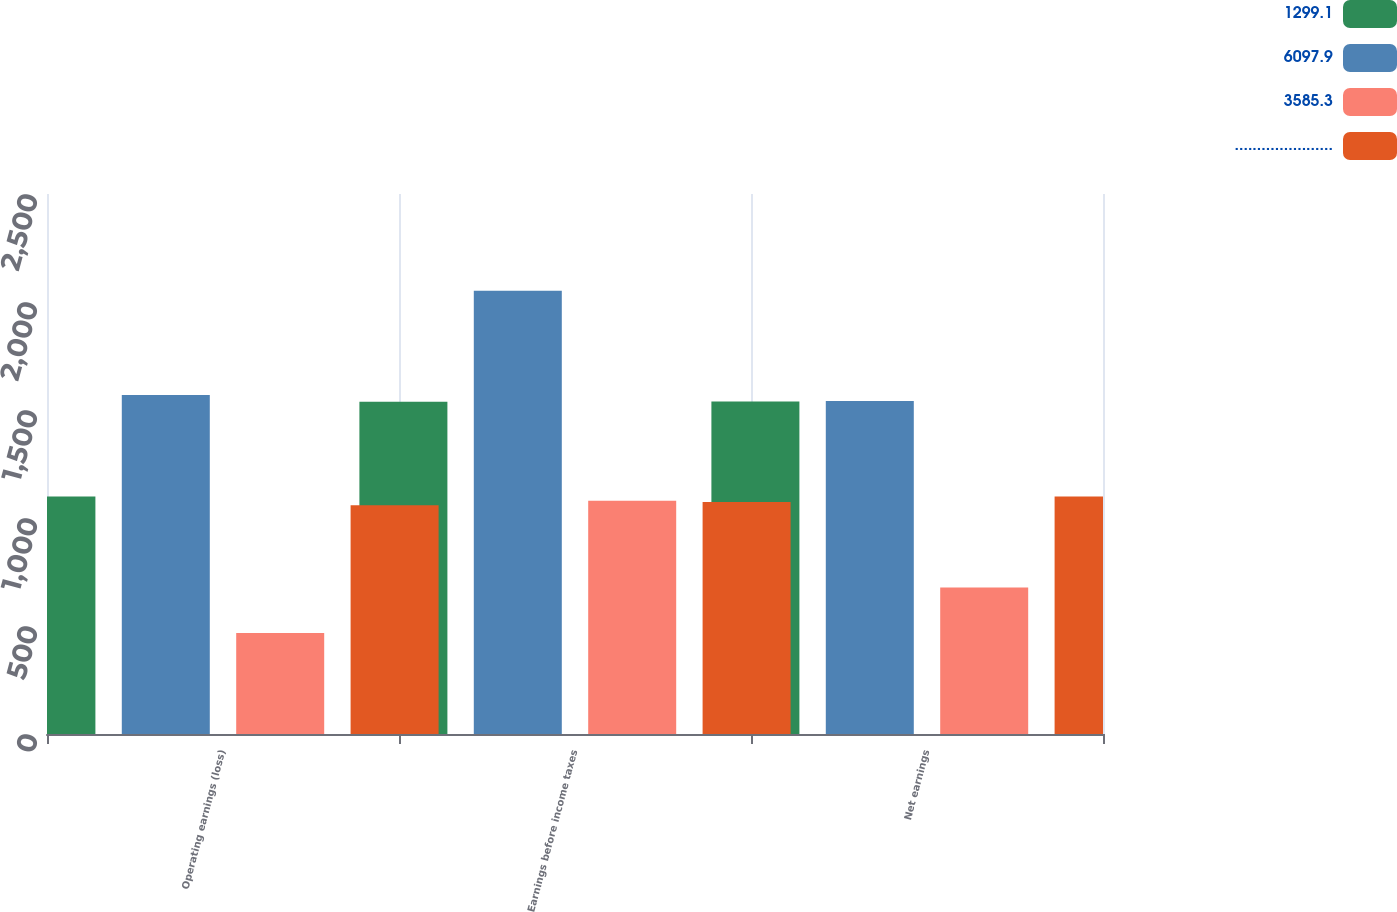<chart> <loc_0><loc_0><loc_500><loc_500><stacked_bar_chart><ecel><fcel>Operating earnings (loss)<fcel>Earnings before income taxes<fcel>Net earnings<nl><fcel>1299.1<fcel>1100<fcel>1537.9<fcel>1539.2<nl><fcel>6097.9<fcel>1569.4<fcel>2051.9<fcel>1541.5<nl><fcel>3585.3<fcel>467.3<fcel>1079.4<fcel>678.5<nl><fcel>......................<fcel>1058.7<fcel>1074.6<fcel>1100<nl></chart> 